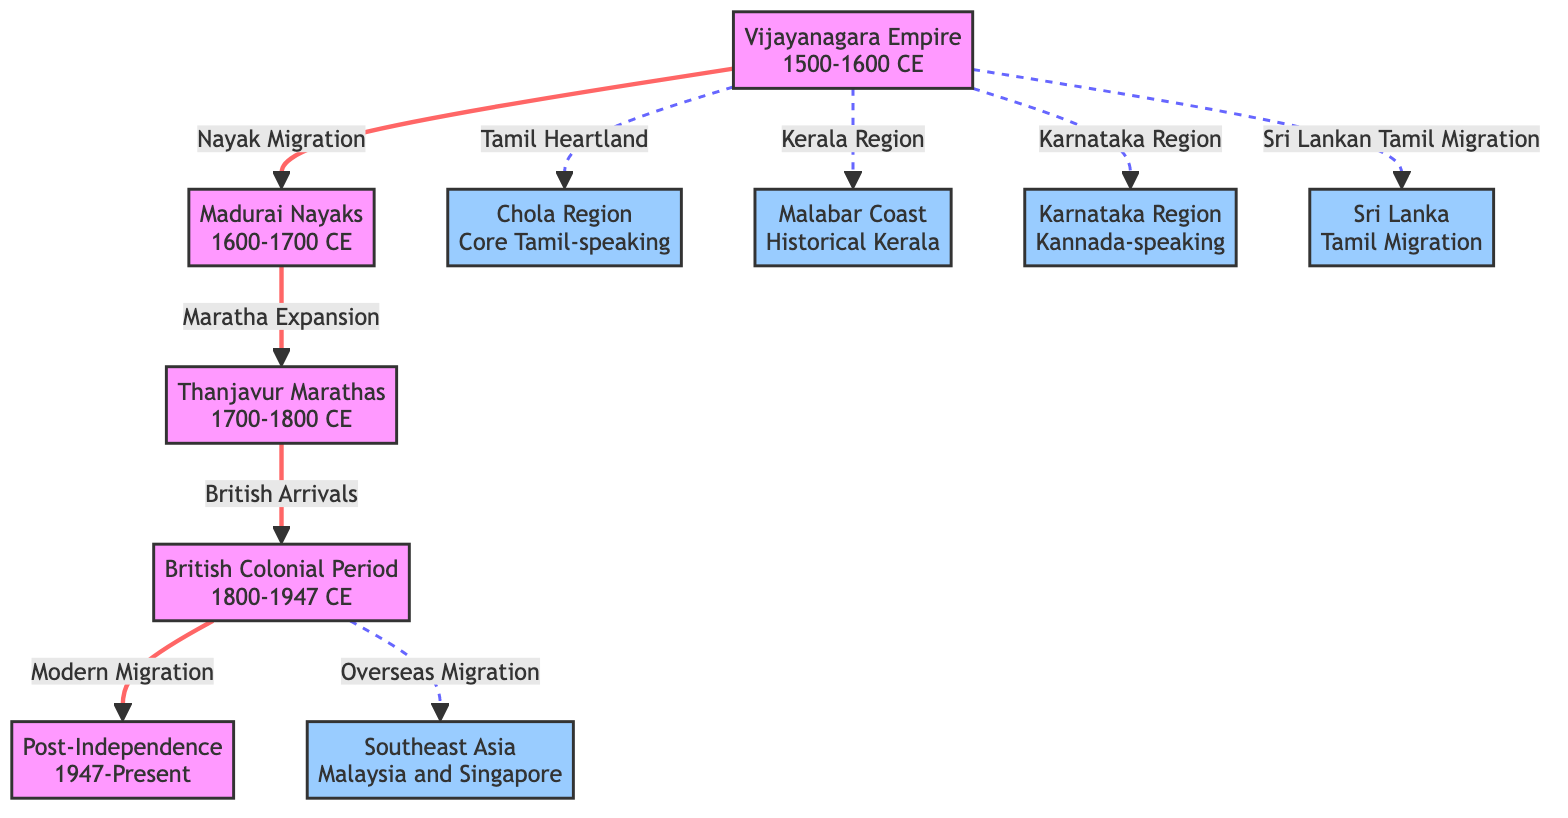What is the first historical migration period depicted in the diagram? The diagram indicates that the first historical migration period is associated with the Vijayanagara Empire, which is labeled in the diagram from the year 1500 to 1600 CE.
Answer: Vijayanagara Empire 1500-1600 CE How many main historical migration periods are shown in the diagram? The diagram outlines five main historical migration periods: Vijayanagara Empire, Madurai Nayaks, Thanjavur Marathas, British Colonial Period, and Post-Independence.
Answer: 5 Which region is associated with the British Colonial Period migration? The British Colonial Period migration has a direct link to the overseas migration to Southeast Asia, as represented by the dashed line connecting them in the diagram.
Answer: Southeast Asia What type of migration did Madurai Nayaks influence? The Madurai Nayaks' influence led to the Maratha expansion, which is represented by the directed arrow connecting Madurai Nayaks to Thanjavur Marathas in the diagram.
Answer: Maratha Expansion What region is adjacent to the Tamil Heartland in the diagram? The Tamil Heartland is located adjacent to the Kerala region, both of which are indicated with dashed lines stemming from the Vijayanagara Empire period in the diagram.
Answer: Kerala Region Which two migrations are labeled as connecting historical periods directly to modern migration? The connections indicate that the Thanjavur Marathas and British Colonial Period directly lead to modern migration, represented by arrows leading to the Post-Independence period.
Answer: Thanjavur Marathas and British Colonial Period What is the significance of the dashed lines in the diagram? The dashed lines in the diagram signify indirect relationships, showing the associations of the Vijayanagara Empire with multiple regions like the Tamil Heartland, Kerala Region, Karnataka Region, and Sri Lankan Tamil Migration.
Answer: Indirect relationships What migration route is represented by the arrow leading into the Post-Independence period? The arrow leading into the Post-Independence period is labeled "Modern Migration," indicating the contemporary movements of people from South Indian communities following India's independence in 1947.
Answer: Modern Migration 